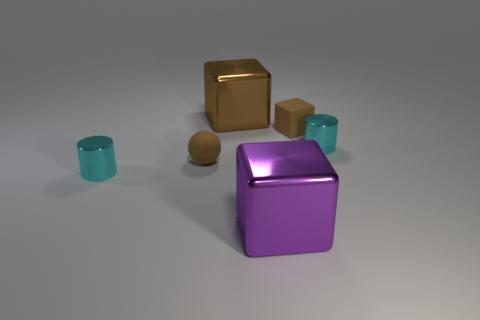Add 2 small objects. How many objects exist? 8 Subtract all cylinders. How many objects are left? 4 Subtract 0 gray balls. How many objects are left? 6 Subtract all large purple blocks. Subtract all big brown shiny things. How many objects are left? 4 Add 3 brown objects. How many brown objects are left? 6 Add 1 small metallic cylinders. How many small metallic cylinders exist? 3 